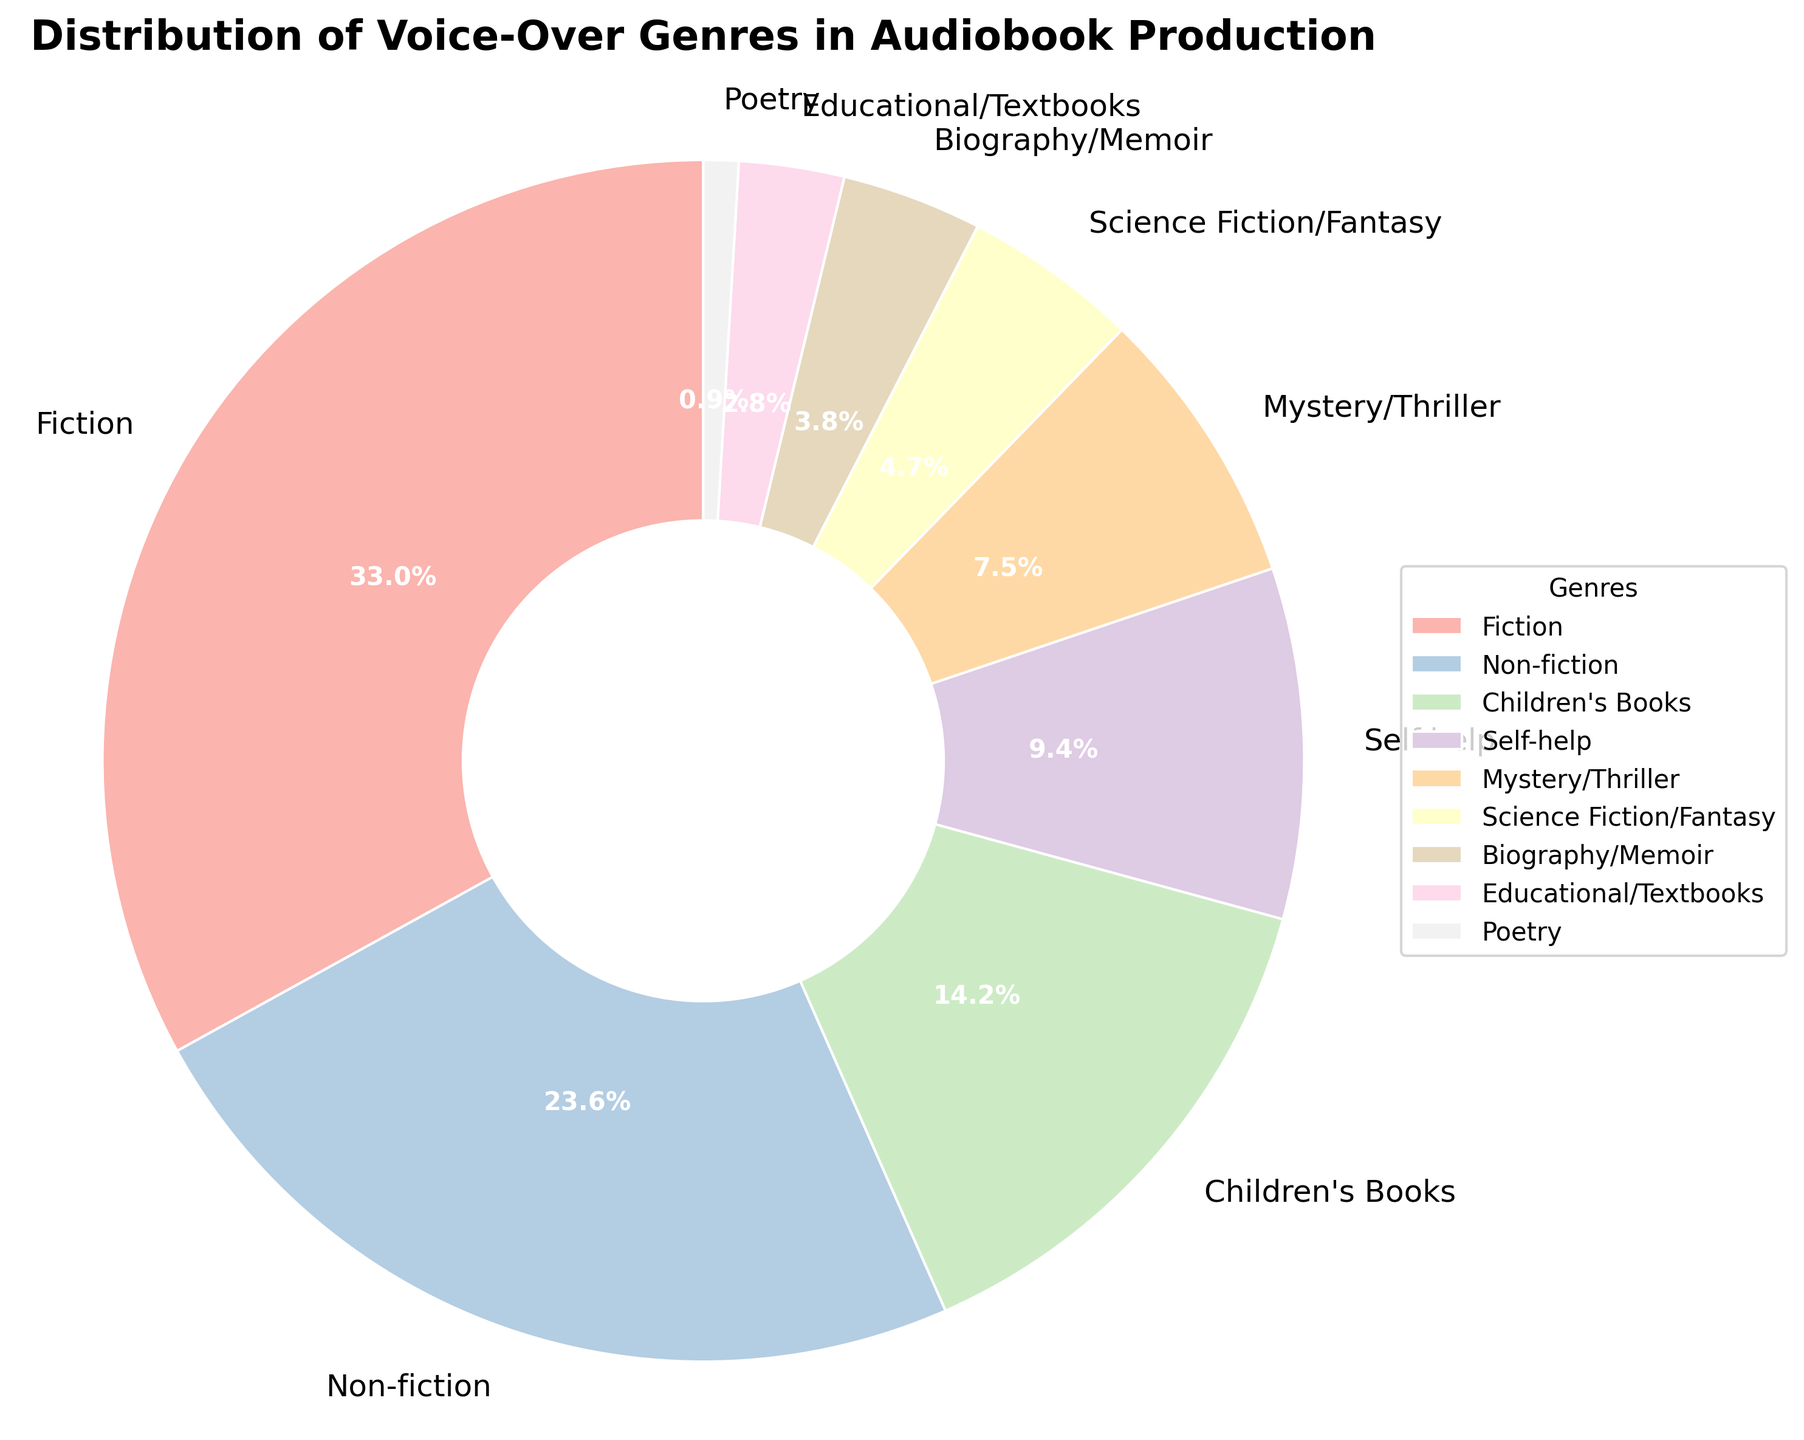Which genre has the highest percentage in audiobook production? The pie chart shows that "Fiction" occupies the largest segment. By looking at the percentages, we see that Fiction has 35%, which is the highest among all genres.
Answer: Fiction How much more percentage does Fiction have compared to Non-fiction? Fiction holds 35% of the distribution, whereas Non-fiction has 25%. The difference is calculated by subtracting the percentage of Non-fiction from Fiction: 35% - 25% = 10%.
Answer: 10% What is the combined percentage of Science Fiction/Fantasy and Mystery/Thriller? The percentage for Science Fiction/Fantasy is 5% and for Mystery/Thriller is 8%. Adding these two values: 5% + 8% = 13%.
Answer: 13% Which genre has the smallest percentage and what is it? The pie chart shows that "Poetry" has the smallest segment. Looking at the percentages, Poetry has 1%, which is the smallest among all genres.
Answer: Poetry, 1% Between Self-help and Educational/Textbooks, which genre has a higher percentage and by how much? Self-help has a percentage of 10%, while Educational/Textbooks has 3%. Subtracting the percentage of Educational/Textbooks from Self-help gives: 10% - 3% = 7%. Self-help has a higher percentage by 7%.
Answer: Self-help, 7% What is the total percentage of genres that are under 10% each? The genres under 10% are Mystery/Thriller (8%), Science Fiction/Fantasy (5%), Biography/Memoir (4%), Educational/Textbooks (3%), and Poetry (1%). Adding these percentages together: 8% + 5% + 4% + 3% + 1% = 21%.
Answer: 21% Which genre segments are visually represented in the light blue shade? The light blue shade in the pie chart generally corresponds to "Educational/Textbooks". According to the color palette and the data provided, Educational/Textbooks is likely represented by the light blue segment.
Answer: Educational/Textbooks How does the percentage of Children's Books compare to that of Science Fiction/Fantasy? Children's Books have a percentage of 15%, while Science Fiction/Fantasy has 5%. Children's Books have a higher percentage. The difference is 15% - 5% = 10%.
Answer: Children's Books, 10% If you combine the percentages of Non-fiction and Self-help, how does this sum compare to Fiction's percentage? Non-fiction has 25% and Self-help has 10%. Combined, they make 25% + 10% = 35%. This combined percentage is equal to the percentage of Fiction, which is also 35%.
Answer: Equal, 35% What is the difference in percentage between the highest and lowest represented genres? The highest represented genre is Fiction at 35%, and the lowest is Poetry at 1%. The difference is calculated by subtracting the lowest percentage from the highest: 35% - 1% = 34%.
Answer: 34% 